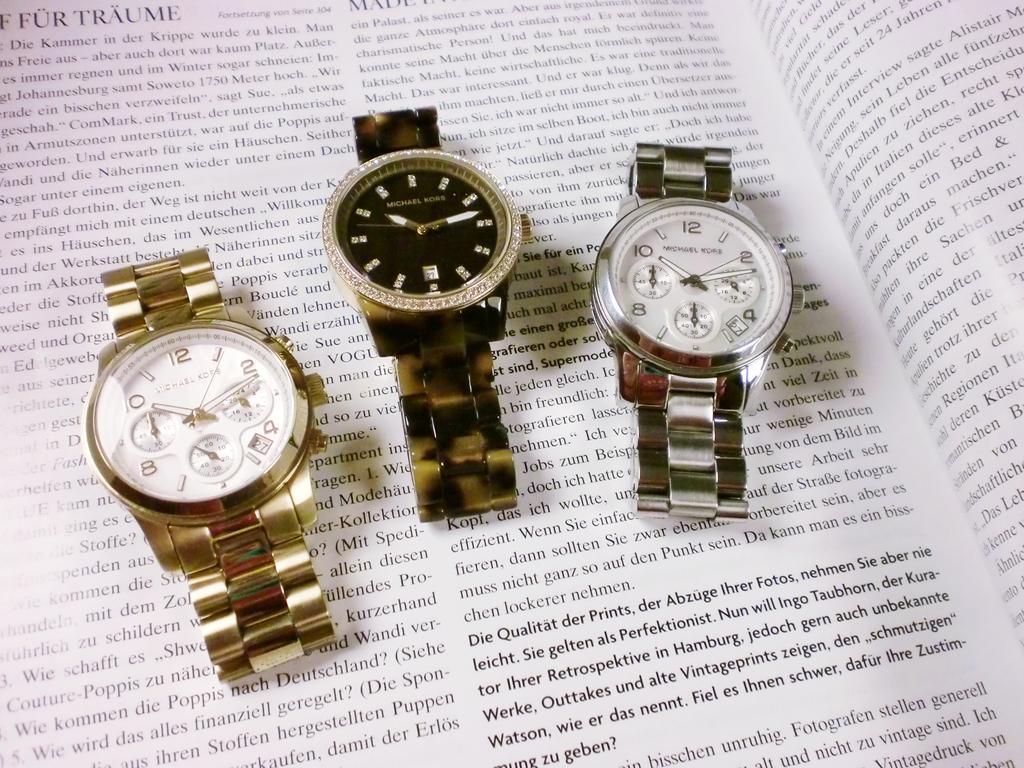Please provide a concise description of this image. In this image there are three different watches kept on the book. 